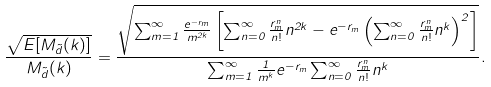<formula> <loc_0><loc_0><loc_500><loc_500>\frac { \sqrt { E [ M _ { \tilde { d } } ( k ) ] } } { M _ { \tilde { d } } ( k ) } = \frac { \sqrt { \sum _ { m = 1 } ^ { \infty } \frac { e ^ { - r _ { m } } } { m ^ { 2 k } } \left [ \sum _ { n = 0 } ^ { \infty } \frac { r _ { m } ^ { n } } { n ! } n ^ { 2 k } - e ^ { - r _ { m } } \left ( \sum _ { n = 0 } ^ { \infty } \frac { r _ { m } ^ { n } } { n ! } n ^ { k } \right ) ^ { 2 } \right ] } } { \sum _ { m = 1 } ^ { \infty } \frac { 1 } { m ^ { k } } e ^ { - r _ { m } } \sum _ { n = 0 } ^ { \infty } \frac { r _ { m } ^ { n } } { n ! } n ^ { k } } .</formula> 